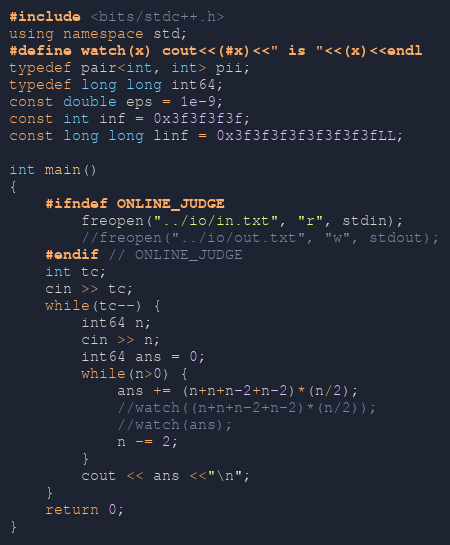<code> <loc_0><loc_0><loc_500><loc_500><_C++_>#include <bits/stdc++.h>
using namespace std;
#define watch(x) cout<<(#x)<<" is "<<(x)<<endl
typedef pair<int, int> pii;
typedef long long int64;
const double eps = 1e-9;
const int inf = 0x3f3f3f3f;
const long long linf = 0x3f3f3f3f3f3f3f3fLL;

int main()
{
    #ifndef ONLINE_JUDGE
	    freopen("../io/in.txt", "r", stdin);
	    //freopen("../io/out.txt", "w", stdout);
    #endif // ONLINE_JUDGE
    int tc;
    cin >> tc;
    while(tc--) {
        int64 n;
        cin >> n;
        int64 ans = 0;
        while(n>0) {
            ans += (n+n+n-2+n-2)*(n/2);
            //watch((n+n+n-2+n-2)*(n/2));
            //watch(ans);
            n -= 2;
        }
        cout << ans <<"\n";
    }
    return 0;
}

</code> 